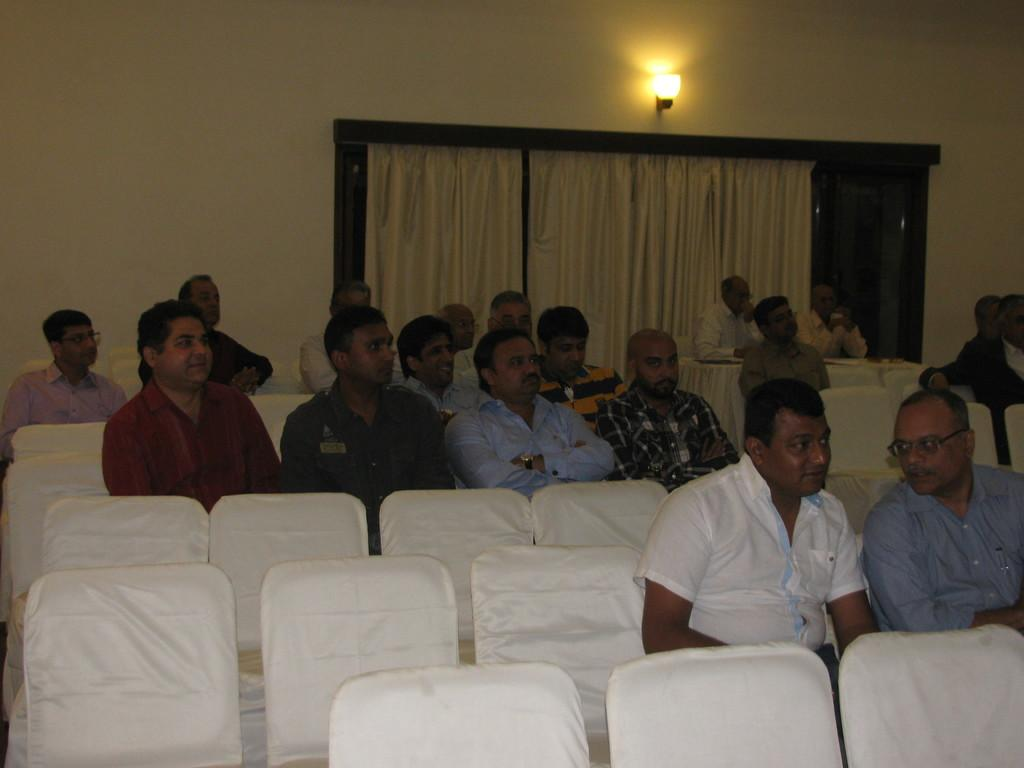Where was the image taken? The image was taken in a function hall. What can be seen in the image besides the people and chairs? There is a curtain and a lamp in the background of the image, and the wall is painted white. What type of net can be seen in the image? There is no net present in the image. Can you describe the grass in the image? There is no grass present in the image. 